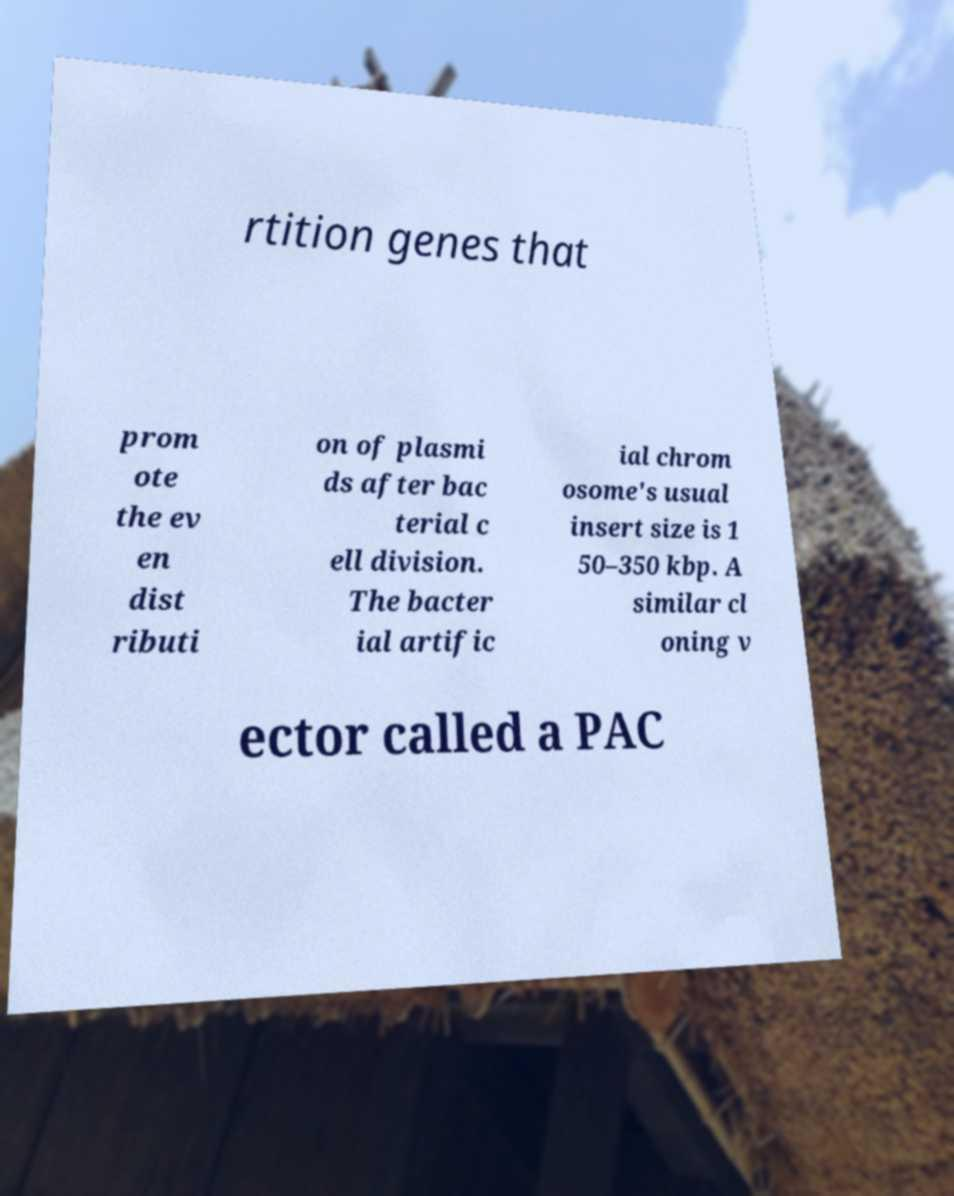Can you accurately transcribe the text from the provided image for me? rtition genes that prom ote the ev en dist ributi on of plasmi ds after bac terial c ell division. The bacter ial artific ial chrom osome's usual insert size is 1 50–350 kbp. A similar cl oning v ector called a PAC 